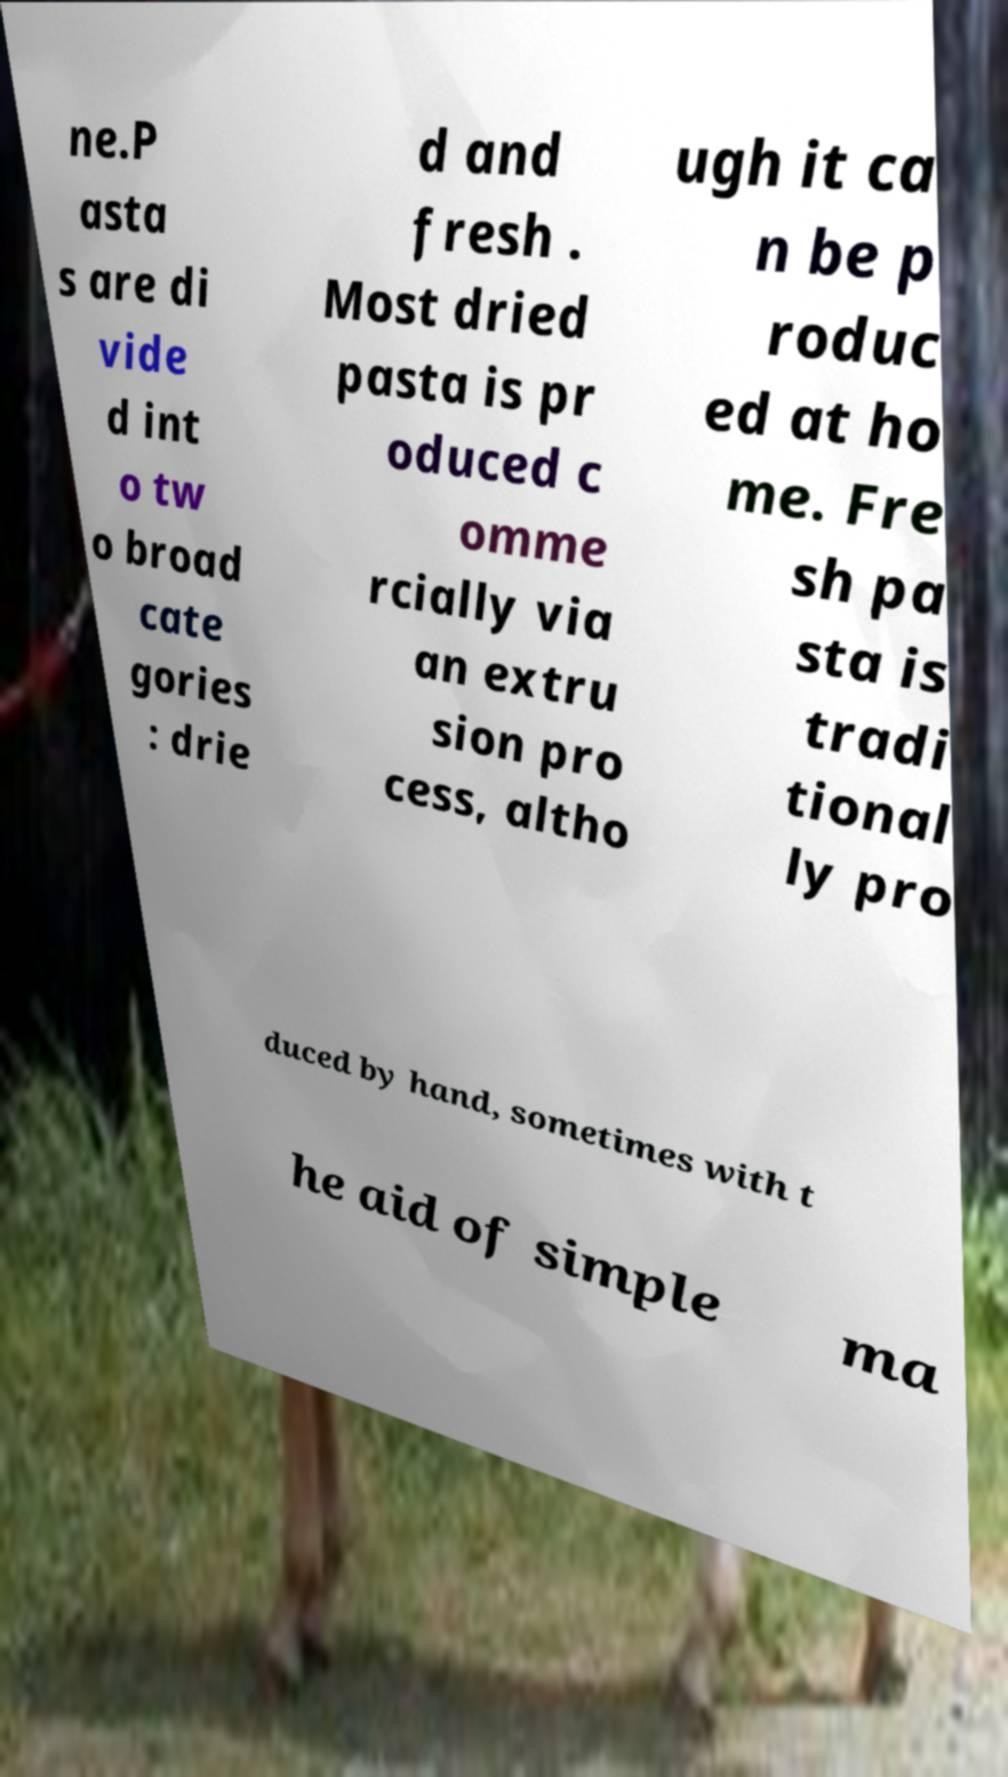Please identify and transcribe the text found in this image. ne.P asta s are di vide d int o tw o broad cate gories : drie d and fresh . Most dried pasta is pr oduced c omme rcially via an extru sion pro cess, altho ugh it ca n be p roduc ed at ho me. Fre sh pa sta is tradi tional ly pro duced by hand, sometimes with t he aid of simple ma 